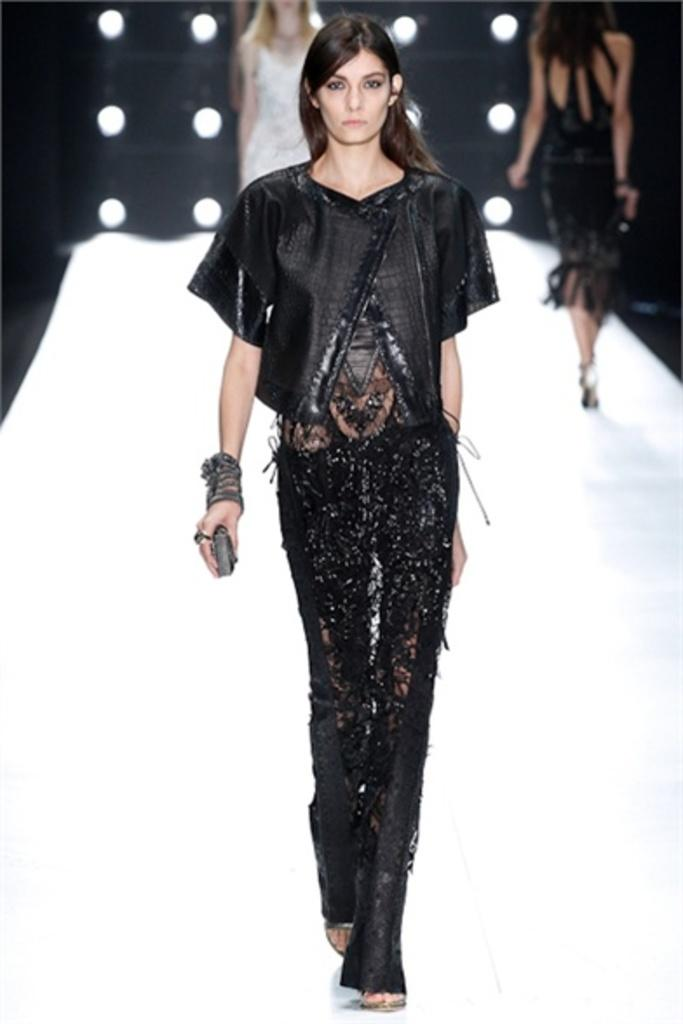Who is present in the image? There are women in the image. What are the women doing in the image? The women are walking on a dais. What type of event might be taking place in the image? The scene resembles a fashion show. What can be seen in the background of the image? There are lights visible in the background. Can you see a guitar being played by one of the women in the image? No, there is no guitar present in the image. Are there any snakes visible on the dais with the women? No, there are no snakes visible in the image. 